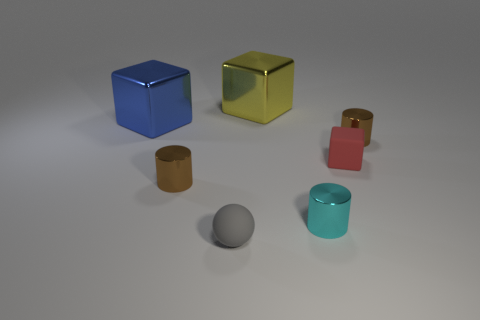Subtract all brown metallic cylinders. How many cylinders are left? 1 Add 1 tiny blocks. How many objects exist? 8 Subtract all yellow cubes. How many cubes are left? 2 Subtract all balls. How many objects are left? 6 Subtract 2 blocks. How many blocks are left? 1 Subtract 0 yellow balls. How many objects are left? 7 Subtract all yellow cubes. Subtract all cyan cylinders. How many cubes are left? 2 Subtract all gray cylinders. How many yellow cubes are left? 1 Subtract all red things. Subtract all big blue metal things. How many objects are left? 5 Add 4 big shiny cubes. How many big shiny cubes are left? 6 